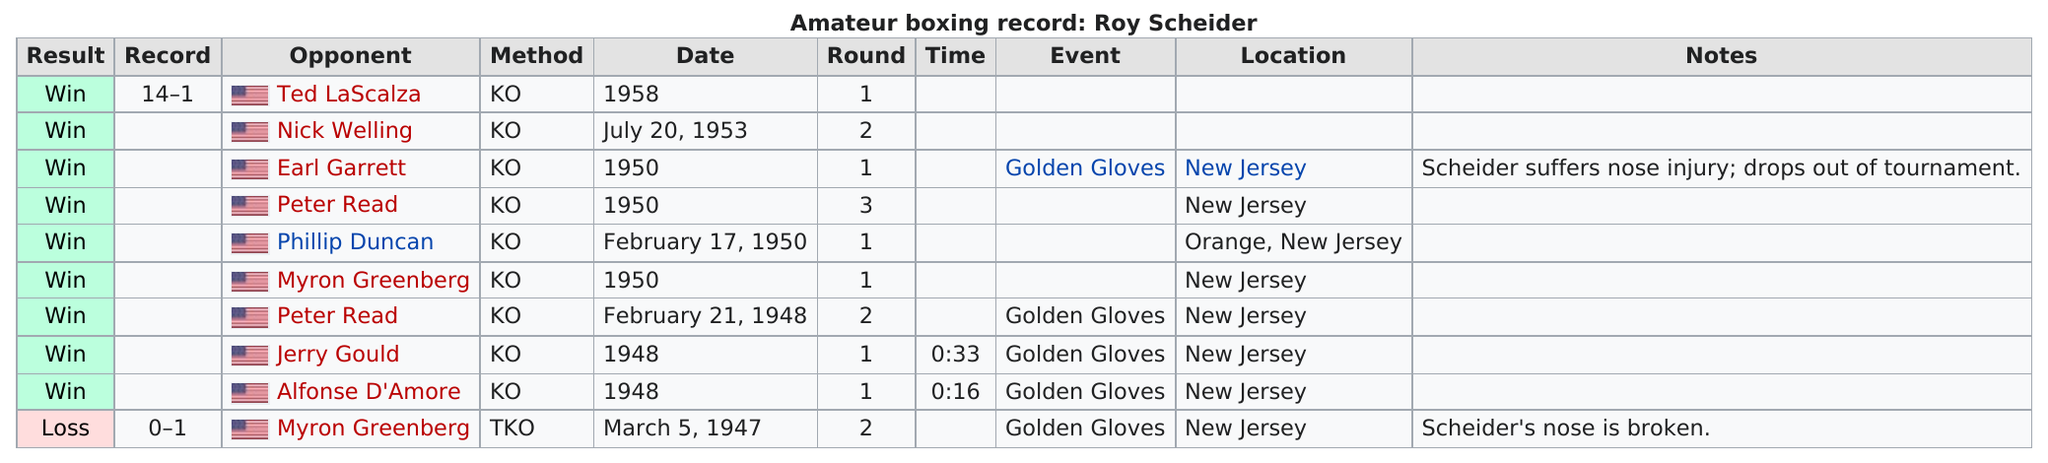Identify some key points in this picture. Scheider appeared in the Golden Gloves event a total of 5 times. It is known that Robert Scheider only lost to Myron Greenberg, making him the only person to have defeated him in competition. In what year did Scheider suffer a nose injury? I posit that it was in 1950. 